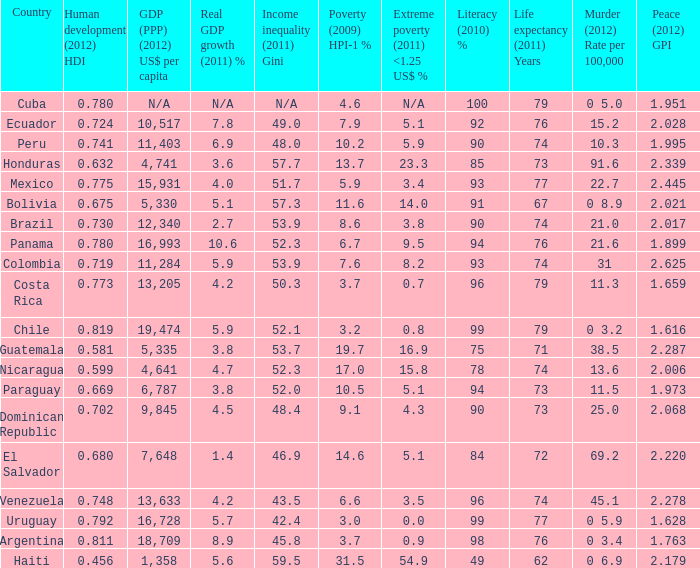What is the total poverty (2009) HPI-1 % when the extreme poverty (2011) <1.25 US$ % of 16.9, and the human development (2012) HDI is less than 0.581? None. 